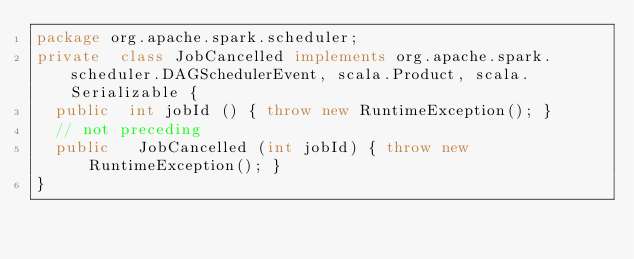<code> <loc_0><loc_0><loc_500><loc_500><_Java_>package org.apache.spark.scheduler;
private  class JobCancelled implements org.apache.spark.scheduler.DAGSchedulerEvent, scala.Product, scala.Serializable {
  public  int jobId () { throw new RuntimeException(); }
  // not preceding
  public   JobCancelled (int jobId) { throw new RuntimeException(); }
}
</code> 